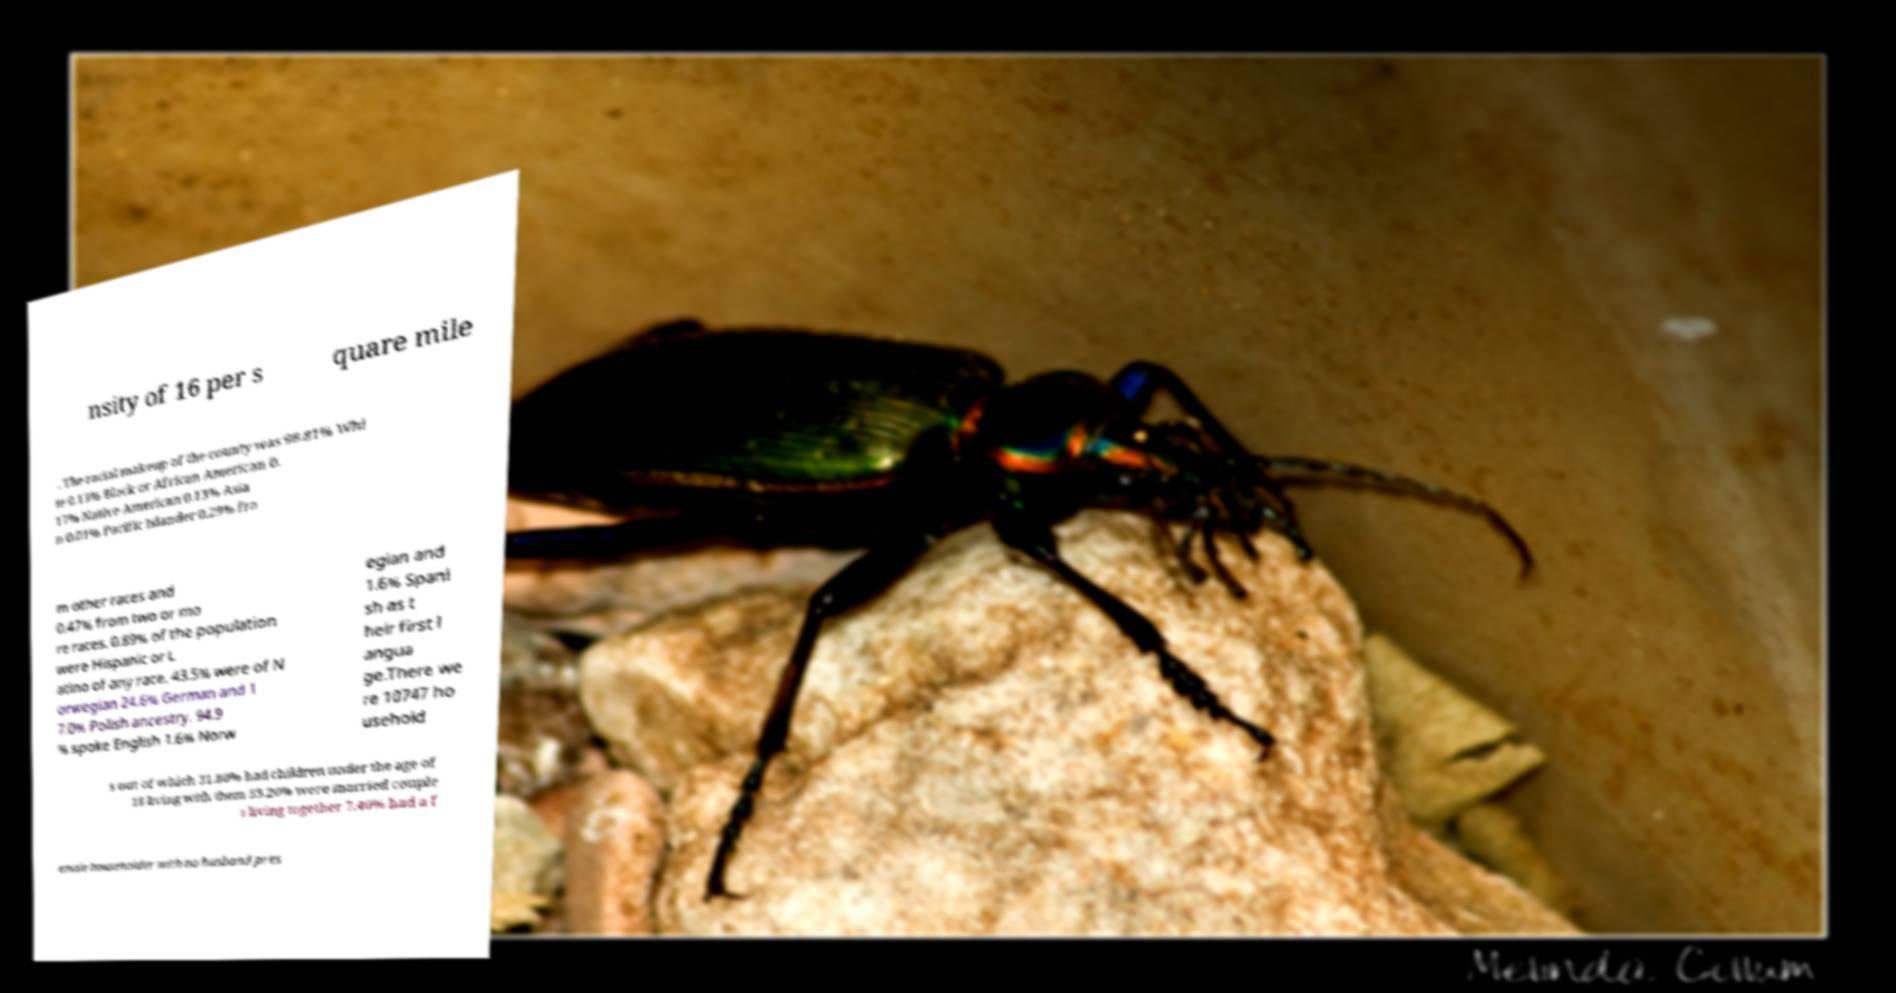For documentation purposes, I need the text within this image transcribed. Could you provide that? nsity of 16 per s quare mile . The racial makeup of the county was 98.81% Whi te 0.13% Black or African American 0. 17% Native American 0.13% Asia n 0.01% Pacific Islander 0.29% fro m other races and 0.47% from two or mo re races. 0.89% of the population were Hispanic or L atino of any race. 43.5% were of N orwegian 24.6% German and 1 7.0% Polish ancestry. 94.9 % spoke English 1.6% Norw egian and 1.6% Spani sh as t heir first l angua ge.There we re 10747 ho usehold s out of which 31.80% had children under the age of 18 living with them 55.20% were married couple s living together 7.40% had a f emale householder with no husband pres 